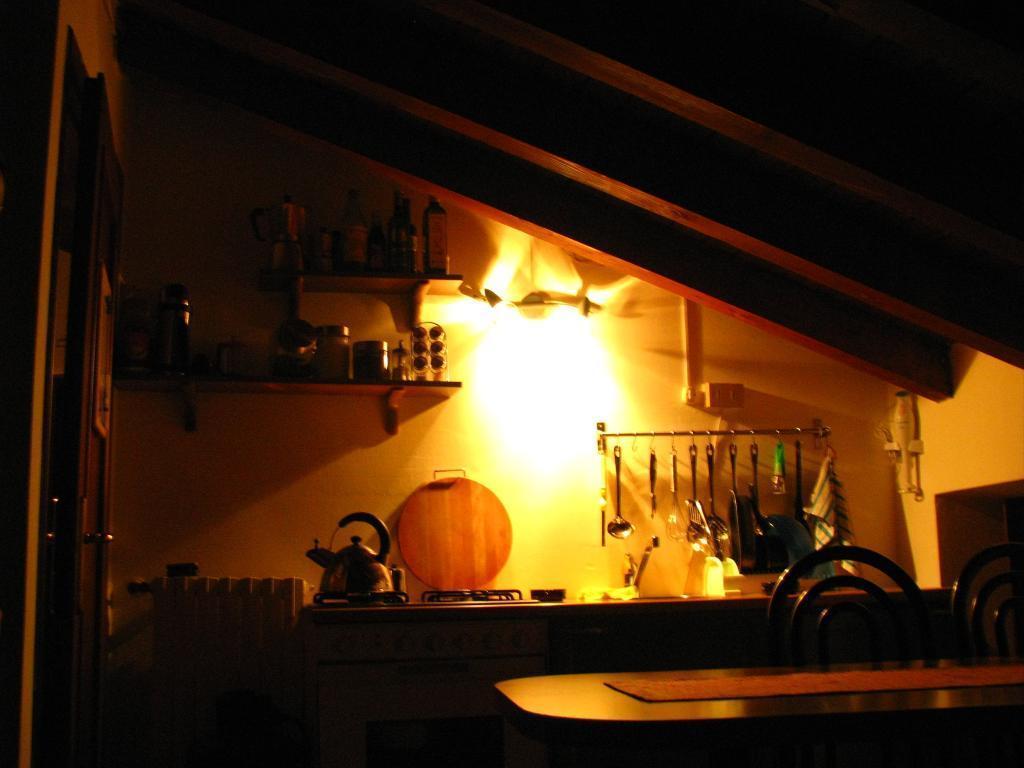Could you give a brief overview of what you see in this image? The picture seems to be in a kitchen room ,on the left side there is tea kettle and wooden pan. On the right side there are spoons and knife and on the top there are vessels. 